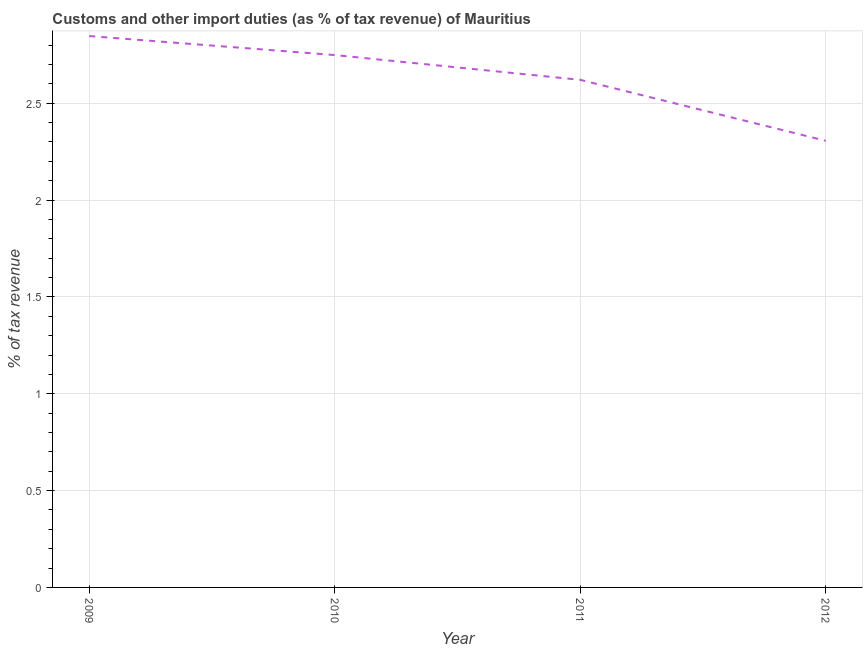What is the customs and other import duties in 2010?
Offer a very short reply. 2.75. Across all years, what is the maximum customs and other import duties?
Offer a very short reply. 2.85. Across all years, what is the minimum customs and other import duties?
Provide a succinct answer. 2.31. What is the sum of the customs and other import duties?
Keep it short and to the point. 10.52. What is the difference between the customs and other import duties in 2010 and 2011?
Provide a succinct answer. 0.13. What is the average customs and other import duties per year?
Provide a short and direct response. 2.63. What is the median customs and other import duties?
Make the answer very short. 2.68. Do a majority of the years between 2009 and 2011 (inclusive) have customs and other import duties greater than 1.2 %?
Provide a short and direct response. Yes. What is the ratio of the customs and other import duties in 2010 to that in 2012?
Provide a succinct answer. 1.19. What is the difference between the highest and the second highest customs and other import duties?
Offer a terse response. 0.1. What is the difference between the highest and the lowest customs and other import duties?
Your response must be concise. 0.54. Does the customs and other import duties monotonically increase over the years?
Offer a terse response. No. What is the difference between two consecutive major ticks on the Y-axis?
Give a very brief answer. 0.5. Does the graph contain any zero values?
Your answer should be very brief. No. What is the title of the graph?
Provide a short and direct response. Customs and other import duties (as % of tax revenue) of Mauritius. What is the label or title of the X-axis?
Give a very brief answer. Year. What is the label or title of the Y-axis?
Keep it short and to the point. % of tax revenue. What is the % of tax revenue of 2009?
Provide a succinct answer. 2.85. What is the % of tax revenue of 2010?
Keep it short and to the point. 2.75. What is the % of tax revenue of 2011?
Provide a short and direct response. 2.62. What is the % of tax revenue in 2012?
Give a very brief answer. 2.31. What is the difference between the % of tax revenue in 2009 and 2010?
Your response must be concise. 0.1. What is the difference between the % of tax revenue in 2009 and 2011?
Keep it short and to the point. 0.23. What is the difference between the % of tax revenue in 2009 and 2012?
Your response must be concise. 0.54. What is the difference between the % of tax revenue in 2010 and 2011?
Give a very brief answer. 0.13. What is the difference between the % of tax revenue in 2010 and 2012?
Offer a very short reply. 0.44. What is the difference between the % of tax revenue in 2011 and 2012?
Offer a terse response. 0.31. What is the ratio of the % of tax revenue in 2009 to that in 2010?
Provide a short and direct response. 1.04. What is the ratio of the % of tax revenue in 2009 to that in 2011?
Provide a succinct answer. 1.09. What is the ratio of the % of tax revenue in 2009 to that in 2012?
Offer a terse response. 1.23. What is the ratio of the % of tax revenue in 2010 to that in 2011?
Your answer should be very brief. 1.05. What is the ratio of the % of tax revenue in 2010 to that in 2012?
Offer a terse response. 1.19. What is the ratio of the % of tax revenue in 2011 to that in 2012?
Your response must be concise. 1.14. 